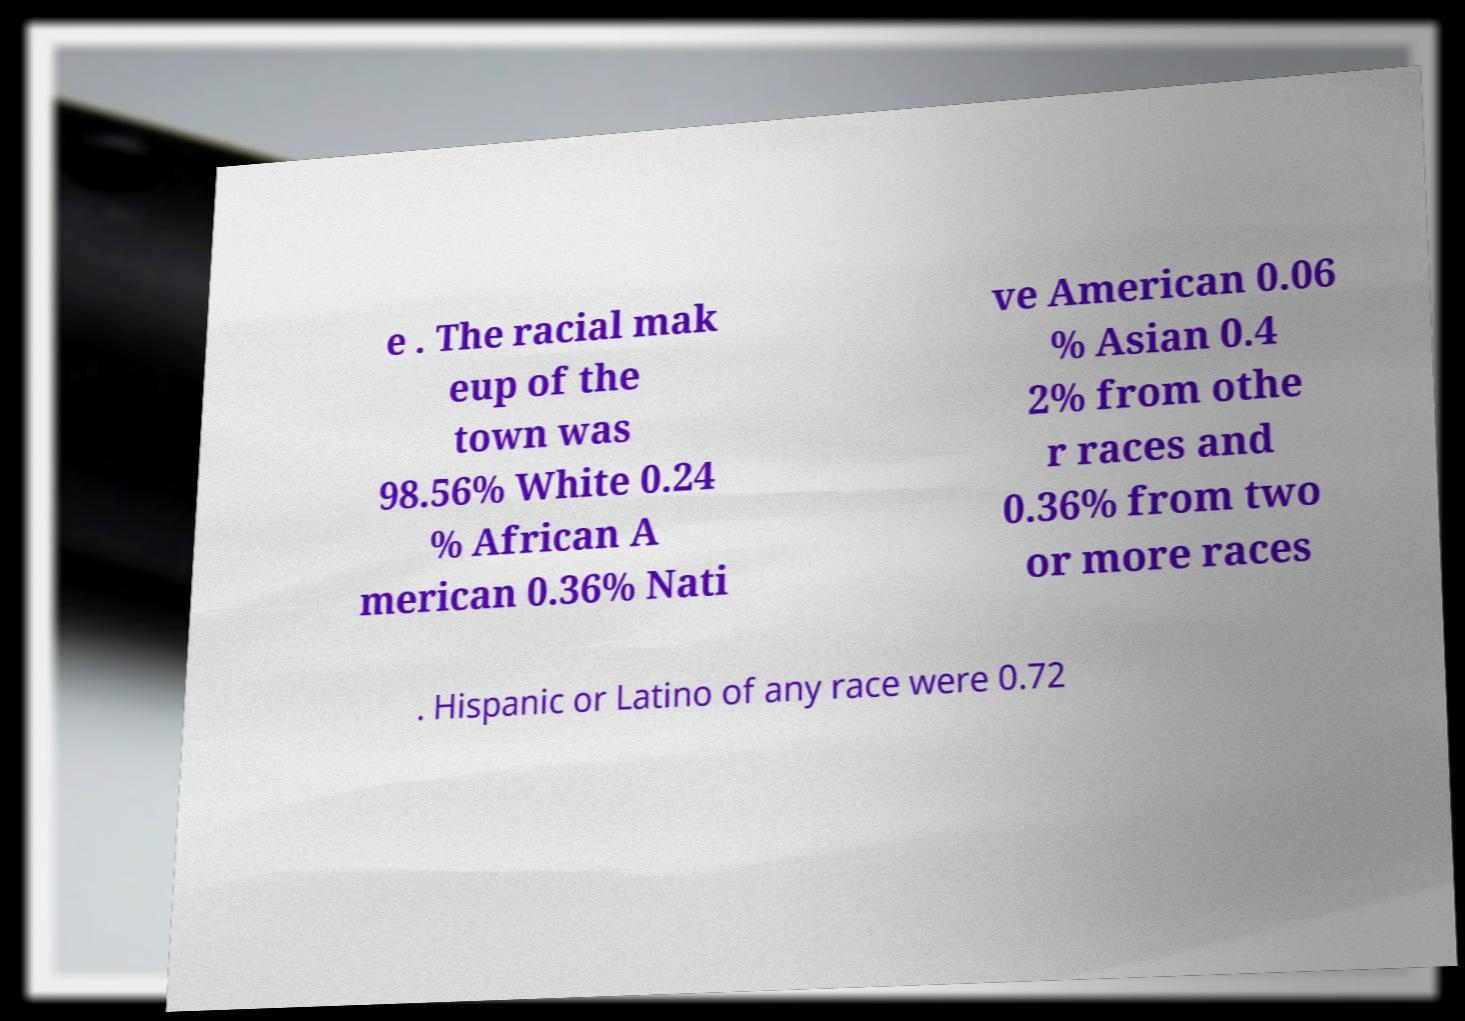Can you read and provide the text displayed in the image?This photo seems to have some interesting text. Can you extract and type it out for me? e . The racial mak eup of the town was 98.56% White 0.24 % African A merican 0.36% Nati ve American 0.06 % Asian 0.4 2% from othe r races and 0.36% from two or more races . Hispanic or Latino of any race were 0.72 